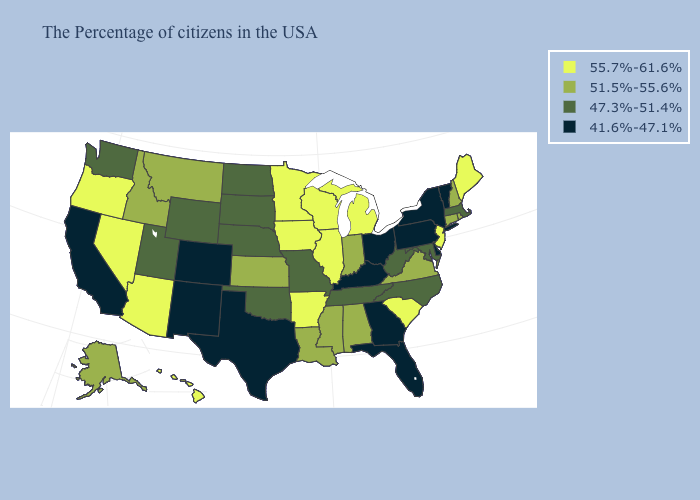What is the value of Kentucky?
Short answer required. 41.6%-47.1%. What is the value of Nebraska?
Concise answer only. 47.3%-51.4%. Does the map have missing data?
Be succinct. No. Name the states that have a value in the range 47.3%-51.4%?
Be succinct. Massachusetts, Maryland, North Carolina, West Virginia, Tennessee, Missouri, Nebraska, Oklahoma, South Dakota, North Dakota, Wyoming, Utah, Washington. Name the states that have a value in the range 47.3%-51.4%?
Answer briefly. Massachusetts, Maryland, North Carolina, West Virginia, Tennessee, Missouri, Nebraska, Oklahoma, South Dakota, North Dakota, Wyoming, Utah, Washington. What is the lowest value in the MidWest?
Be succinct. 41.6%-47.1%. What is the value of Maine?
Keep it brief. 55.7%-61.6%. Which states hav the highest value in the MidWest?
Be succinct. Michigan, Wisconsin, Illinois, Minnesota, Iowa. What is the value of Minnesota?
Quick response, please. 55.7%-61.6%. Which states have the lowest value in the West?
Write a very short answer. Colorado, New Mexico, California. Name the states that have a value in the range 47.3%-51.4%?
Keep it brief. Massachusetts, Maryland, North Carolina, West Virginia, Tennessee, Missouri, Nebraska, Oklahoma, South Dakota, North Dakota, Wyoming, Utah, Washington. Name the states that have a value in the range 51.5%-55.6%?
Give a very brief answer. Rhode Island, New Hampshire, Connecticut, Virginia, Indiana, Alabama, Mississippi, Louisiana, Kansas, Montana, Idaho, Alaska. Does West Virginia have the lowest value in the South?
Quick response, please. No. Name the states that have a value in the range 51.5%-55.6%?
Concise answer only. Rhode Island, New Hampshire, Connecticut, Virginia, Indiana, Alabama, Mississippi, Louisiana, Kansas, Montana, Idaho, Alaska. Does Ohio have the lowest value in the USA?
Be succinct. Yes. 